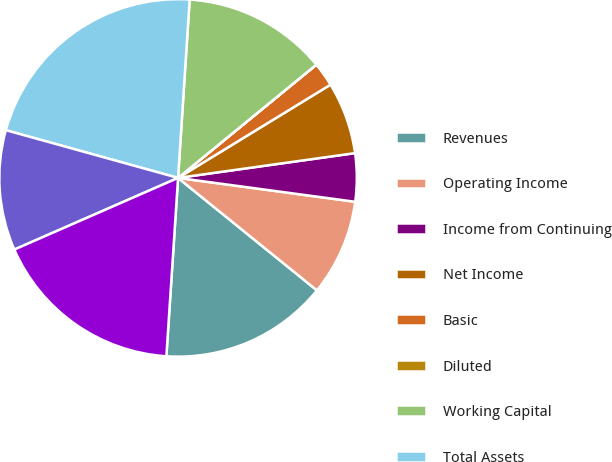<chart> <loc_0><loc_0><loc_500><loc_500><pie_chart><fcel>Revenues<fcel>Operating Income<fcel>Income from Continuing<fcel>Net Income<fcel>Basic<fcel>Diluted<fcel>Working Capital<fcel>Total Assets<fcel>Long-term Obligations<fcel>Shareholders' Equity<nl><fcel>15.21%<fcel>8.7%<fcel>4.35%<fcel>6.52%<fcel>2.18%<fcel>0.01%<fcel>13.04%<fcel>21.73%<fcel>10.87%<fcel>17.39%<nl></chart> 